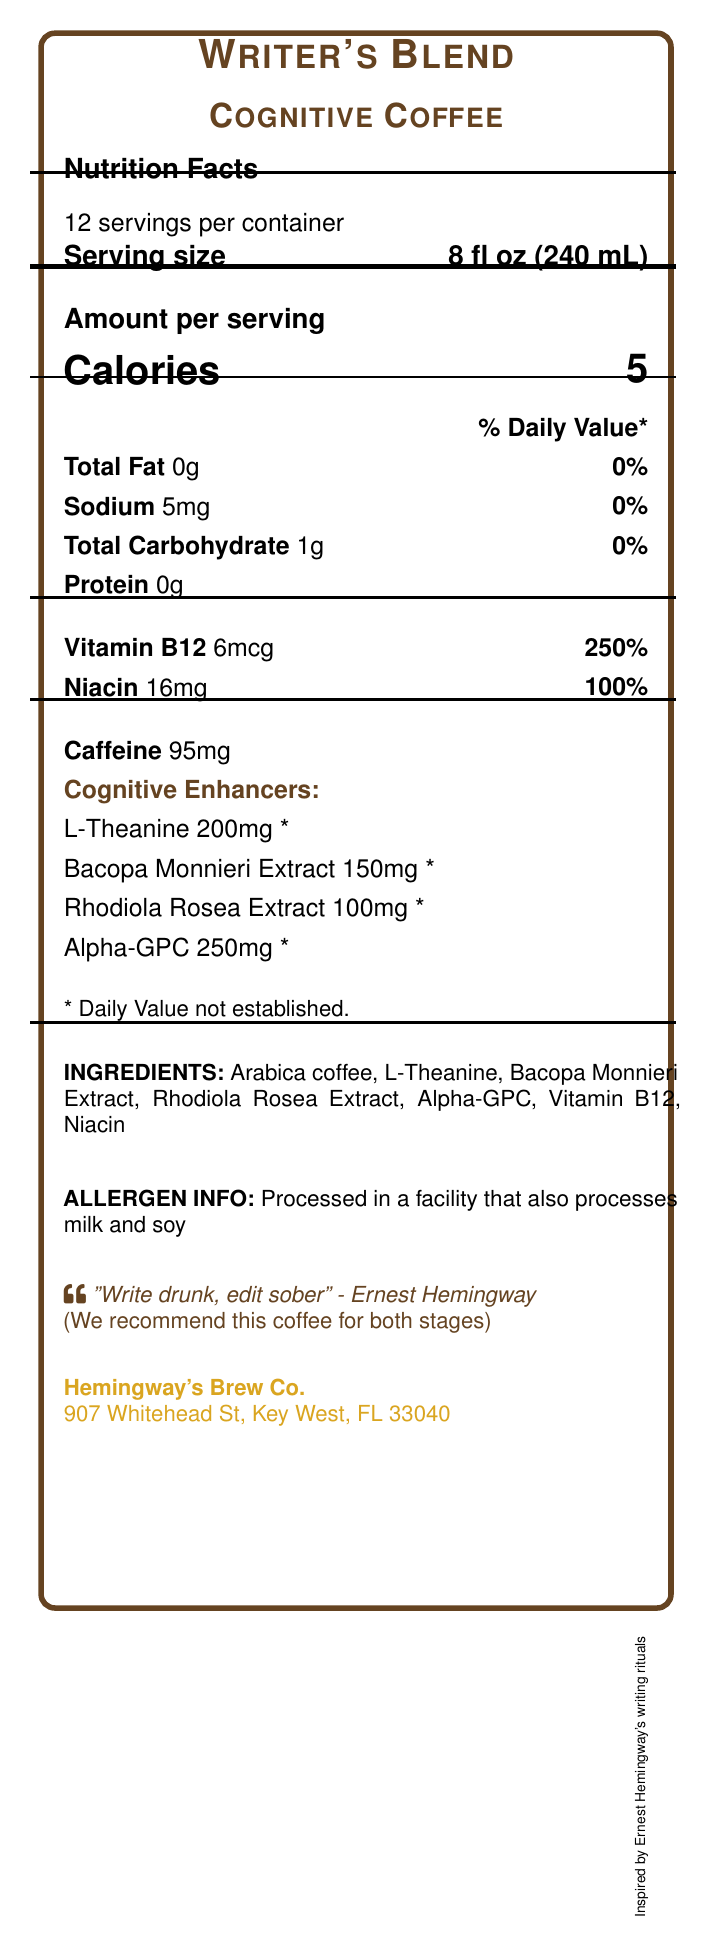what is the serving size of Writer's Blend Cognitive Coffee? The serving size information is stated as 8 fl oz (240 mL) in the Nutrition Facts section of the document.
Answer: 8 fl oz (240 mL) how many calories are there per serving? The document lists the calories per serving as 5 in the Nutrition Facts section.
Answer: 5 what is the amount of caffeine per serving? The amount of caffeine per serving is listed as 95mg under the Nutrition Facts.
Answer: 95mg name one cognitive enhancer in this coffee and its amount per serving One cognitive enhancer listed in the document is L-Theanine, with an amount of 200mg per serving.
Answer: L-Theanine, 200mg how much Niacin is in each serving, and what percentage of the daily value does it represent? The document states there's 16mg of Niacin per serving, which represents 100% of the daily value.
Answer: 16mg, 100% which of the following is not an ingredient in Writer's Blend Cognitive Coffee? A. L-Theanine B. Bacopa Monnieri Extract C. Guarana Extract D. Alpha-GPC The ingredients listed in the document do not include Guarana Extract, although it lists L-Theanine, Bacopa Monnieri Extract, and Alpha-GPC.
Answer: C. Guarana Extract what is the daily value percentage for Vitamin B12 in this coffee? A. 100% B. 150% C. 200% D. 250% The daily value percentage for Vitamin B12 is listed as 250% in the Nutrition Facts section.
Answer: D. 250% is this coffee processed in a facility that also processes milk and soy? The allergen information states that it is processed in a facility that also processes milk and soy.
Answer: Yes summarize the main contents of this document The summary covers the main aspects of the document, including nutrition facts, ingredients, allergen information, and additional contextual details inspired by Ernest Hemingway.
Answer: The document provides the nutrition facts for Writer's Blend Cognitive Coffee, highlighting serving size, calories, fat, sodium, carbohydrates, protein, caffeine, and cognitive enhancers. It lists extensive ingredient details, allergen information, manufacturer info, and some interesting context related to Ernest Hemingway's writing rituals. is there enough information in the document to determine the exact process of making this coffee? The document provides brewing instructions but does not detail the exact process of making the coffee, so the exact process is not entirely clear from the visual information.
Answer: Not enough information where is Hemingway's Brew Co. located? The address given for Hemingway's Brew Co. is 907 Whitehead St, Key West, FL 33040, as stated at the bottom of the Nutrition Facts label.
Answer: Key West, FL 33040 what flavor notes are associated with Writer's Blend Cognitive Coffee? The flavor notes mentioned in the document describe the coffee as bold, with hints of creativity and focus.
Answer: Bold, with hints of creativity and focus 